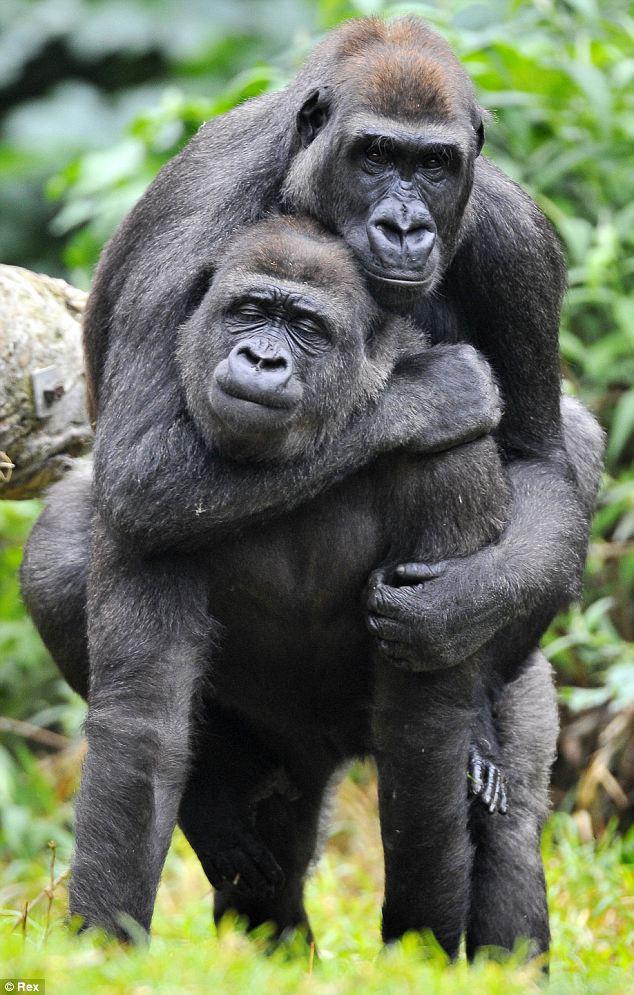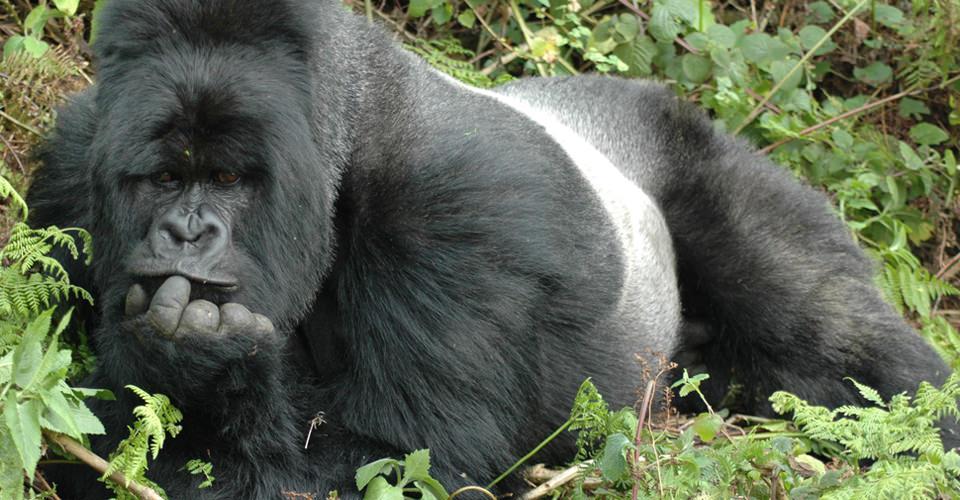The first image is the image on the left, the second image is the image on the right. For the images shown, is this caption "The left image contains exactly two gorillas." true? Answer yes or no. Yes. The first image is the image on the left, the second image is the image on the right. For the images displayed, is the sentence "There are exactly three animals outside." factually correct? Answer yes or no. Yes. The first image is the image on the left, the second image is the image on the right. Examine the images to the left and right. Is the description "There is a gorilla holding another gorilla from the back in one of the images." accurate? Answer yes or no. Yes. 